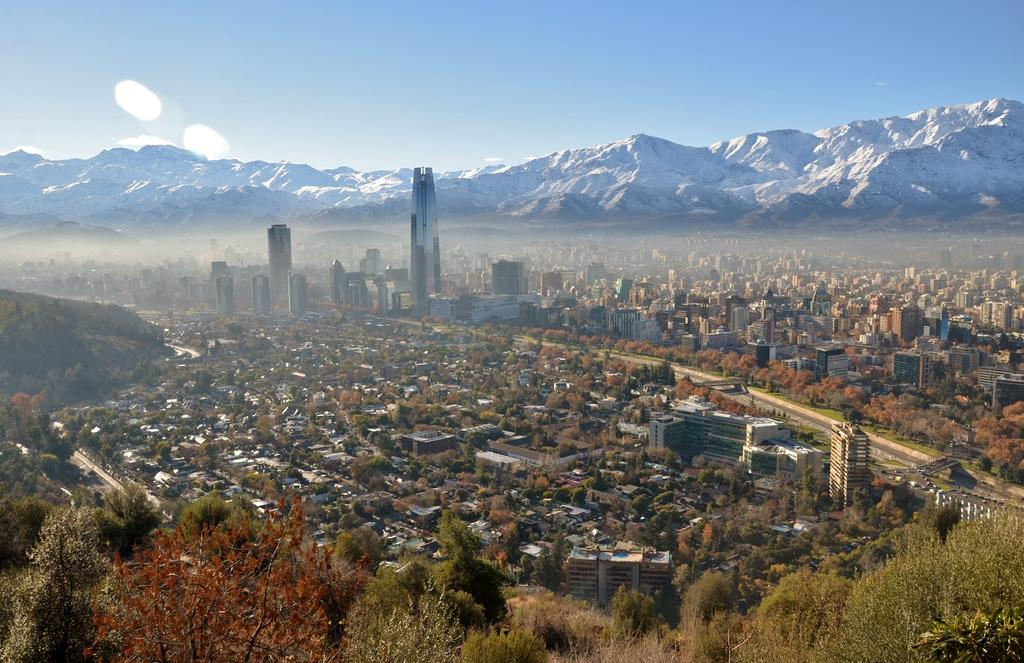What type of vegetation can be seen in the image? There are trees in the image. What type of structures are present in the image? There are buildings in the image. What is at the bottom of the image? There is grass at the bottom of the image. What can be seen in the distance in the image? There are mountains visible in the background of the image. What is visible at the top of the image? The sky is visible at the top of the image. How many turkeys can be seen in the image? There are no turkeys present in the image. What type of wood is used to construct the buildings in the image? The provided facts do not mention the type of wood used to construct the buildings, and there is no indication of wood being used in the image. 